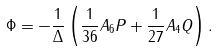<formula> <loc_0><loc_0><loc_500><loc_500>\Phi = - \frac { 1 } { \Delta } \left ( \frac { 1 } { 3 6 } A _ { 6 } P + \frac { 1 } { 2 7 } A _ { 4 } Q \right ) .</formula> 